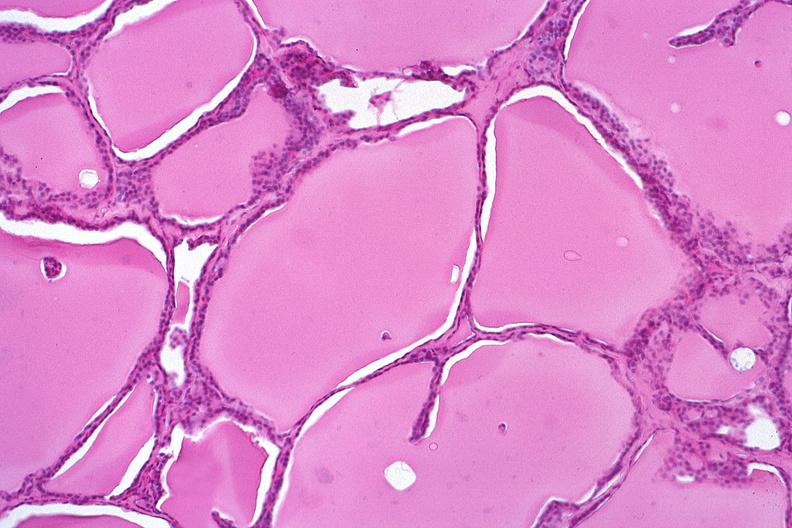what does this image show?
Answer the question using a single word or phrase. Thyroid 